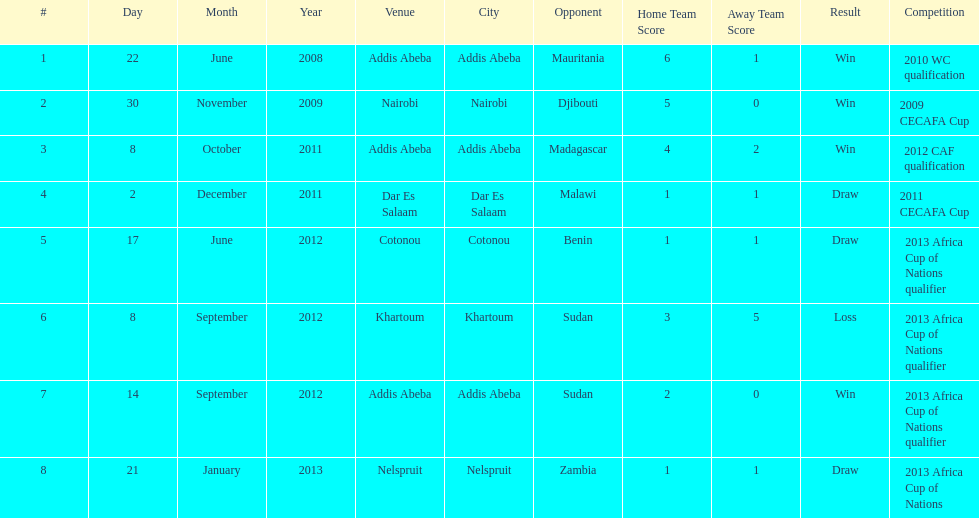Number of different teams listed on the chart 7. 